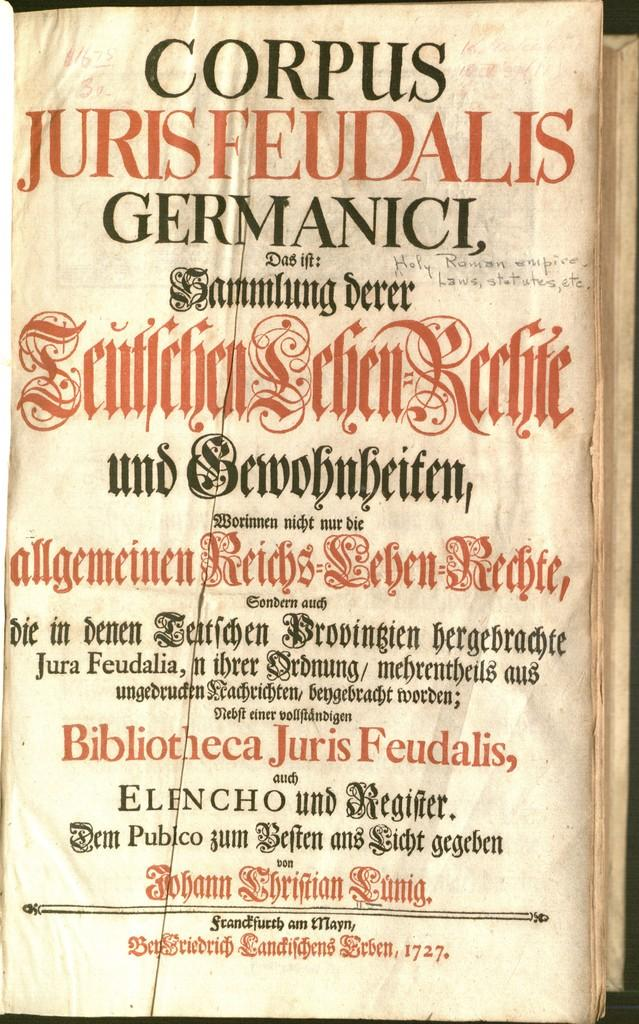<image>
Describe the image concisely. A page from an old book written in a foreign language and has Corpus Germanici in large black letters. 